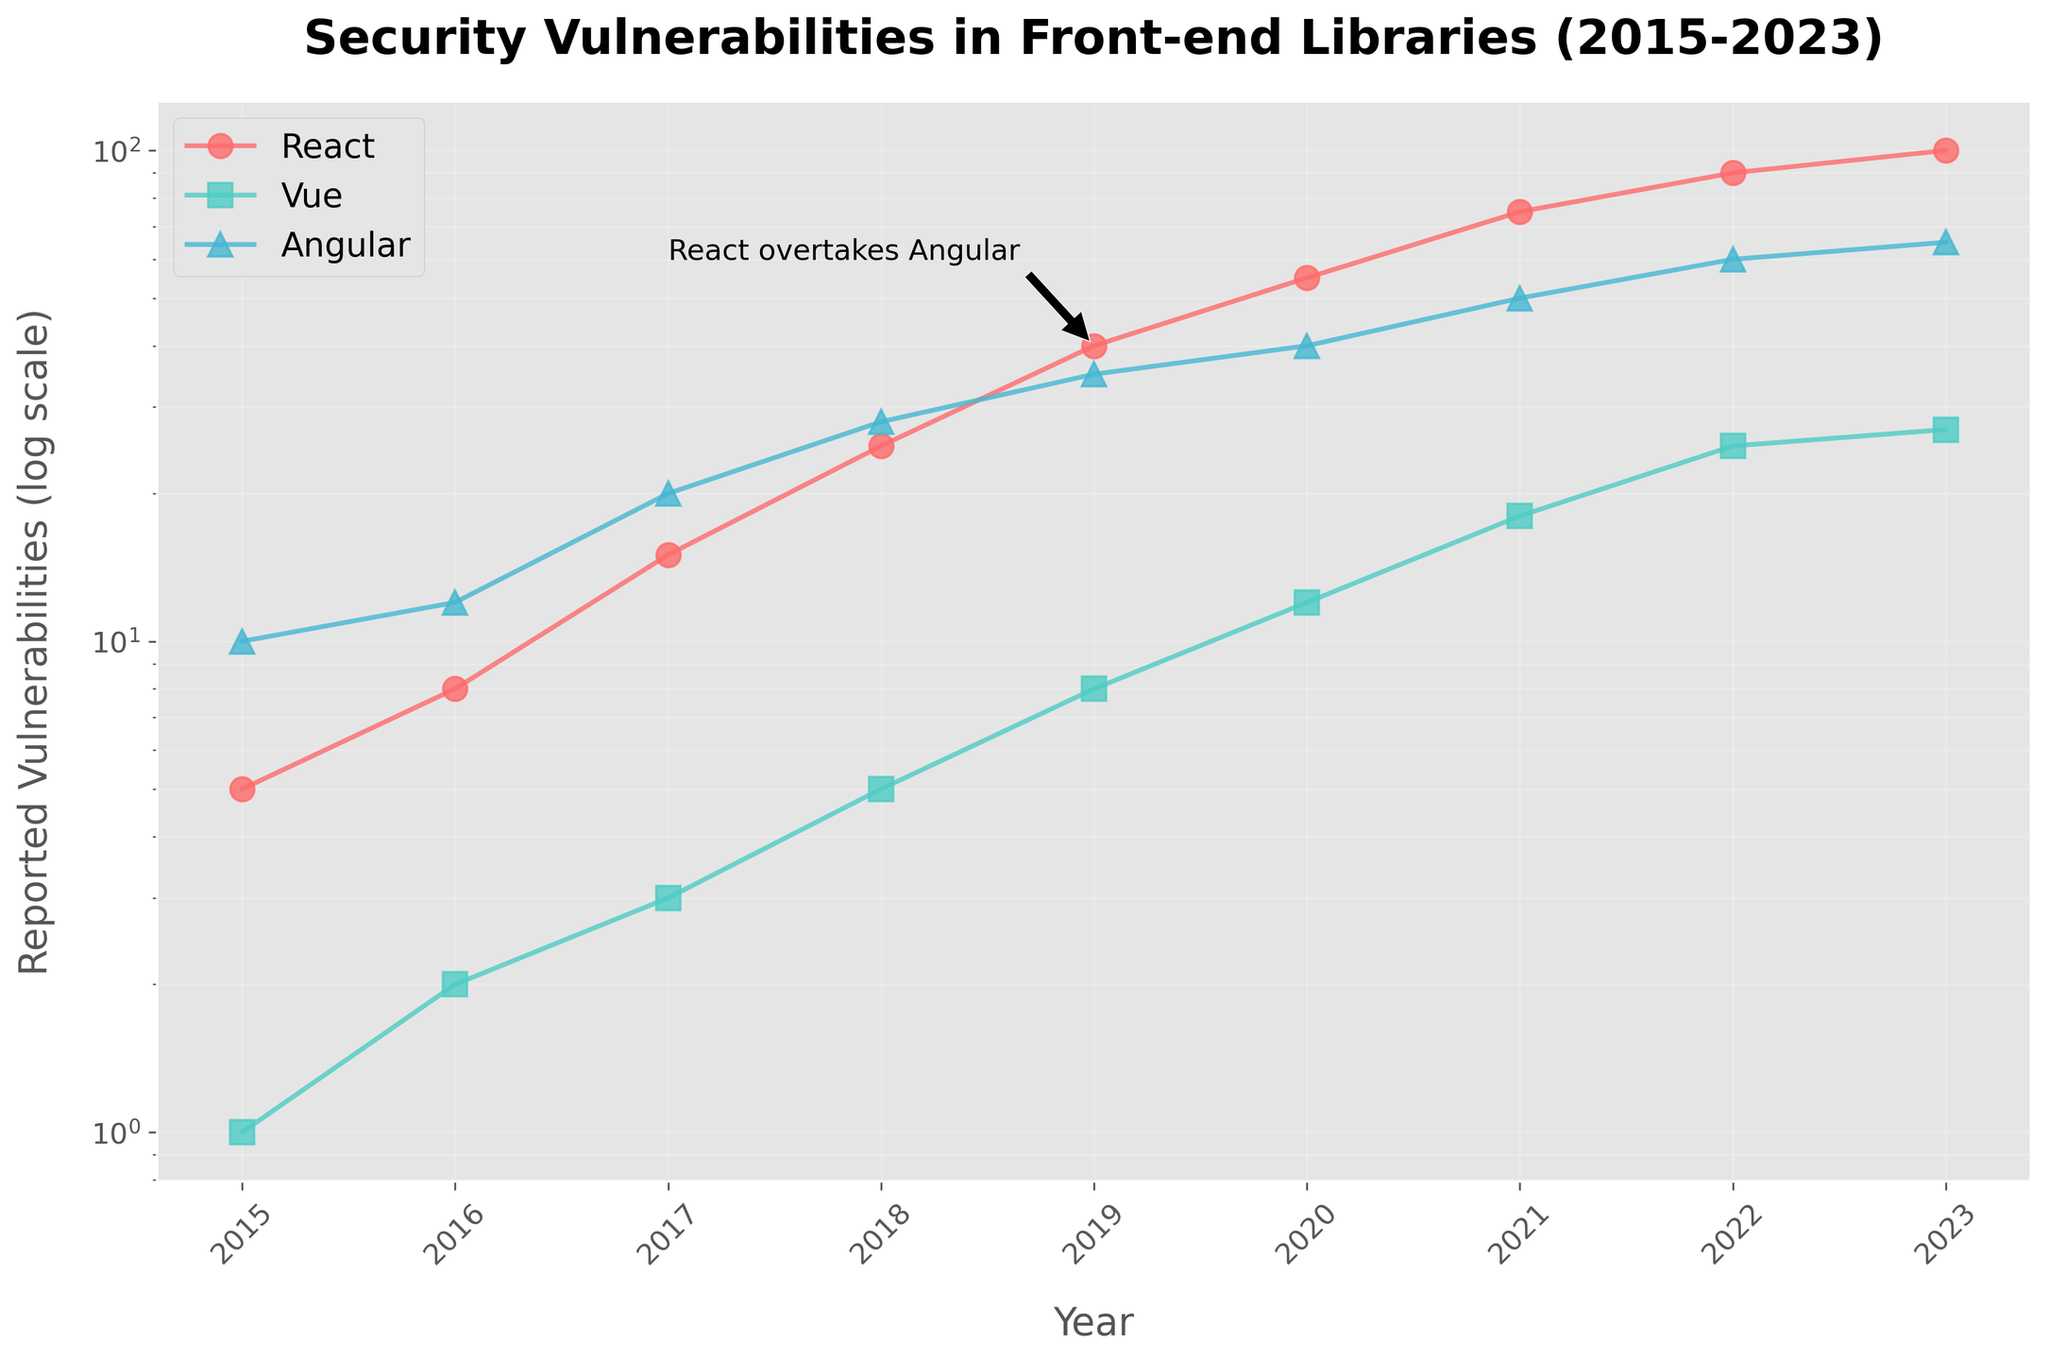How many reported vulnerabilities did React have in 2021? Look for the data point in 2021 for the React line. From the figure, React had 75 reported vulnerabilities in 2021.
Answer: 75 Which library had the least number of reported vulnerabilities in 2015? Compare the data points for all libraries in 2015. React had 5, Vue had 1, and Angular had 10 reported vulnerabilities. Vue had the least.
Answer: Vue In which year did React overtake Angular in the number of reported vulnerabilities? Identify the year where the React line surpasses the Angular line. This occurs in 2019 with React having 40 and Angular having 35 vulnerabilities.
Answer: 2019 What is the range of the reported vulnerabilities for Vue from 2015 to 2023? Find the minimum and maximum values for Vue from the data points between 2015 and 2023. The minimum is 1 in 2015 and the maximum is 27 in 2023. So, the range is 27 - 1 = 26.
Answer: 26 Between 2018 and 2020, how many additional vulnerabilities were reported for Angular? Compute the difference in reported vulnerabilities for Angular between 2018 (28) and 2020 (40): 40 - 28 = 12
Answer: 12 Which library displayed the fastest growth rate in the reported vulnerabilities between 2015 and 2023? Visually compare the slopes of the lines representing React, Vue, and Angular. React shows the steepest increase from 5 (2015) to 100 (2023), indicating the fastest growth rate.
Answer: React How many times more vulnerabilities did React have than Vue in 2023? Compare React and Vue in 2023. React had 100 vulnerabilities, and Vue had 27 vulnerabilities. 100 / 27 ≈ 3.7 times.
Answer: 3.7 times Did any library show a decrease in reported vulnerabilities in any year within the displayed period? Examine the trend lines for all libraries. All lines show an increasing trend from 2015 to 2023, indicating no decrease.
Answer: No What is the approximate percentage increase in reported vulnerabilities for React from 2020 to 2021? Calculate the difference and the percentage increase from 2020 (55) to 2021 (75): (75 - 55) / 55 * 100 ≈ 36.4%.
Answer: 36.4% Between 2016 and 2018, which library had the smallest increase in reported vulnerabilities? Compare the difference in vulnerabilities between 2016 and 2018. React: 25 - 8 = 17, Vue: 5 - 2 = 3, Angular: 28 - 12 = 16. Vue had the smallest increase.
Answer: Vue 